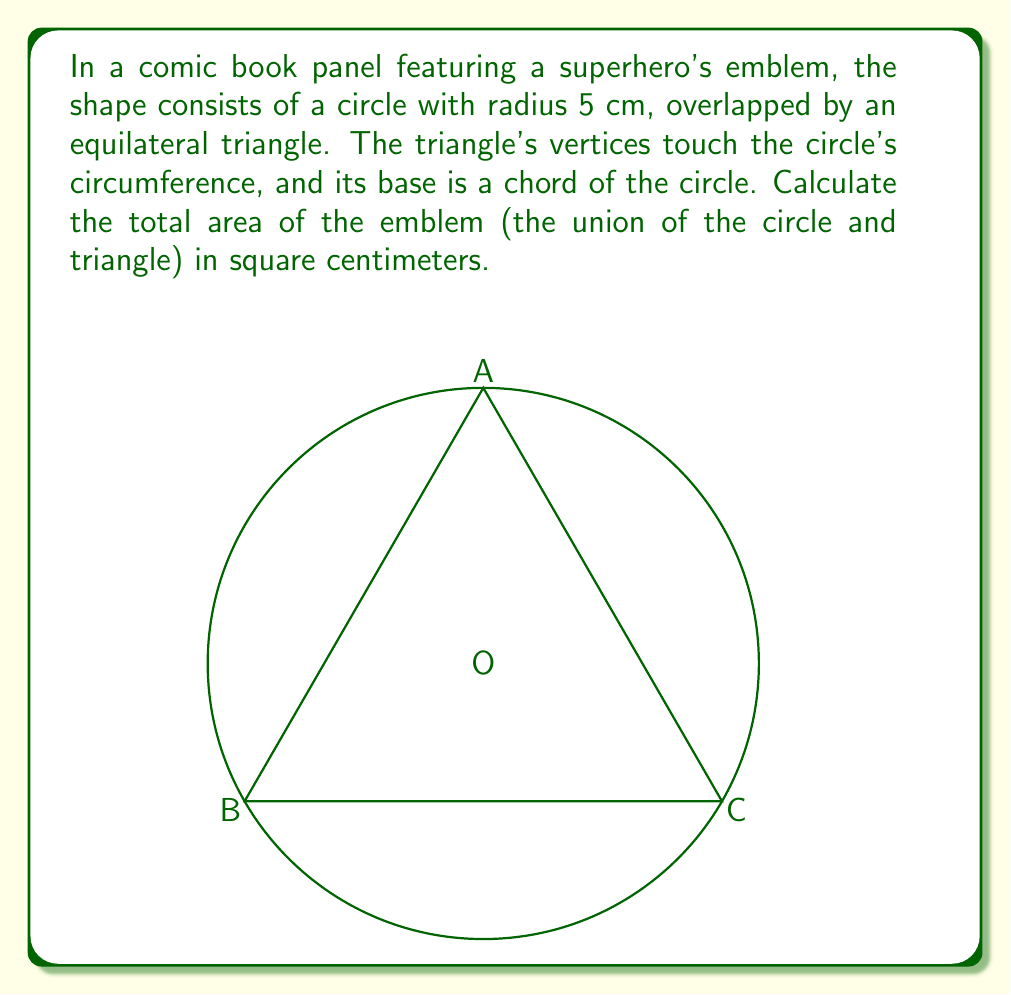Solve this math problem. To solve this problem, we need to calculate the areas of the circle and the equilateral triangle, then subtract the area of their intersection. Let's break it down step by step:

1. Area of the circle:
   $$A_c = \pi r^2 = \pi (5\text{ cm})^2 = 25\pi \text{ cm}^2$$

2. Area of the equilateral triangle:
   First, we need to find the side length of the triangle. In an equilateral triangle inscribed in a circle, the side length $s$ is related to the radius $r$ by:
   $$s = r\sqrt{3}$$
   So, $s = 5\sqrt{3} \text{ cm}$

   The area of an equilateral triangle with side $s$ is:
   $$A_t = \frac{\sqrt{3}}{4}s^2 = \frac{\sqrt{3}}{4}(5\sqrt{3})^2 = \frac{75\sqrt{3}}{4} \text{ cm}^2$$

3. Area of the intersection:
   The intersection forms a circular segment. The area of a circular segment is given by:
   $$A_{\text{segment}} = r^2 \arccos(\frac{r-h}{r}) - (r-h)\sqrt{2rh-h^2}$$
   where $h$ is the height of the segment.

   In our case, $h = r - \frac{\sqrt{3}}{2}r = r(1-\frac{\sqrt{3}}{2})$

   Substituting values:
   $$\begin{align*}
   A_{\text{segment}} &= 5^2 \arccos(\frac{\sqrt{3}}{2}) - 5(1-\frac{\sqrt{3}}{2})\sqrt{2\cdot5\cdot5(1-\frac{\sqrt{3}}{2})-5^2(1-\frac{\sqrt{3}}{2})^2} \\
   &= 25 \arccos(\frac{\sqrt{3}}{2}) - 5(1-\frac{\sqrt{3}}{2})\sqrt{75-25(2-\sqrt{3})} \\
   &\approx 4.0579 \text{ cm}^2
   \end{align*}$$

4. Total area of the emblem:
   $$A_{\text{total}} = A_c + A_t - A_{\text{segment}}$$
   $$= 25\pi + \frac{75\sqrt{3}}{4} - 4.0579$$
   $$\approx 111.7073 \text{ cm}^2$$
Answer: The total area of the superhero emblem is approximately $111.71 \text{ cm}^2$. 